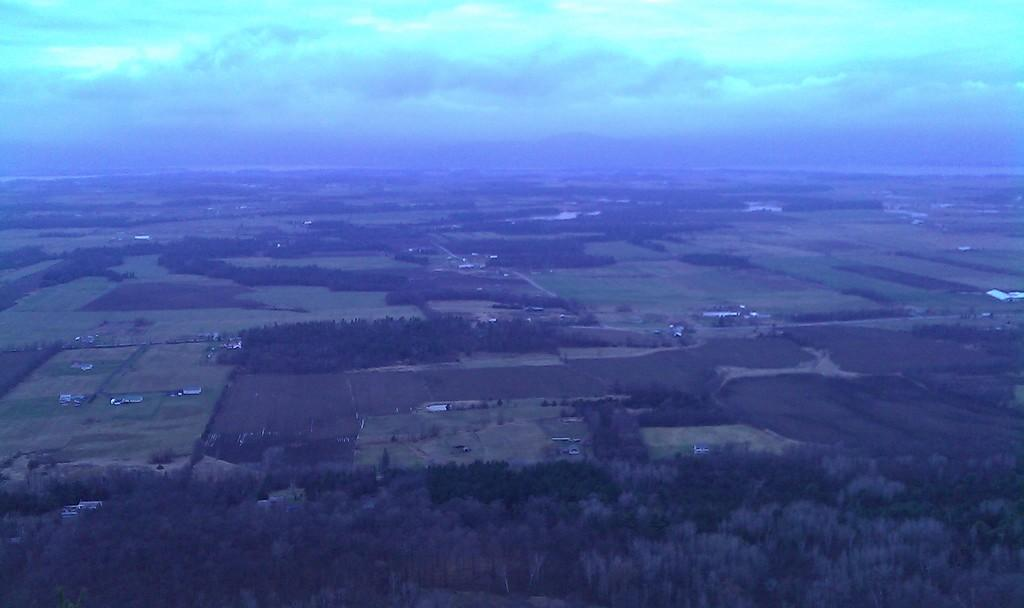What type of view is provided in the image? The image is an aerial view. What type of vegetation can be seen in the image? There are trees visible in the image. What type of terrain is visible in the image? There is grassy land visible in the image. What type of structures can be seen in the image? There are buildings visible in the image. What else is visible in the image besides the land and structures? The sky is visible in the image. Where is the scarecrow standing in the image? There is no scarecrow present in the image. What type of lamp is illuminating the grassy land in the image? There is no lamp present in the image. 